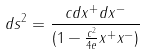<formula> <loc_0><loc_0><loc_500><loc_500>d s ^ { 2 } = \frac { c d x ^ { + } d x ^ { - } } { ( 1 - \frac { c ^ { 2 } } { 4 e } x ^ { + } x ^ { - } ) }</formula> 